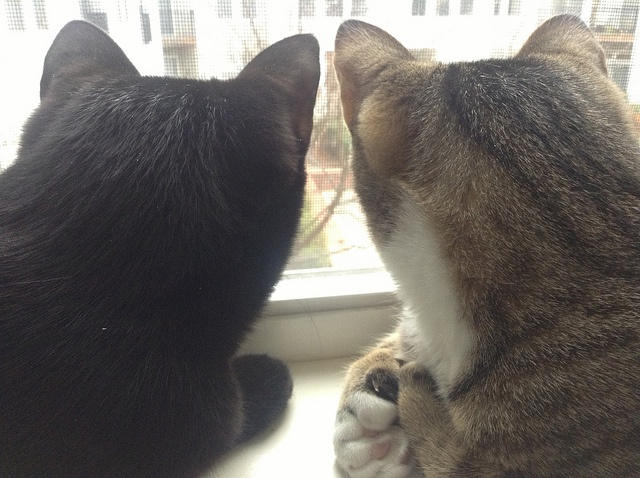Describe the objects in this image and their specific colors. I can see cat in white, gray, black, and darkgray tones and cat in white, black, and gray tones in this image. 